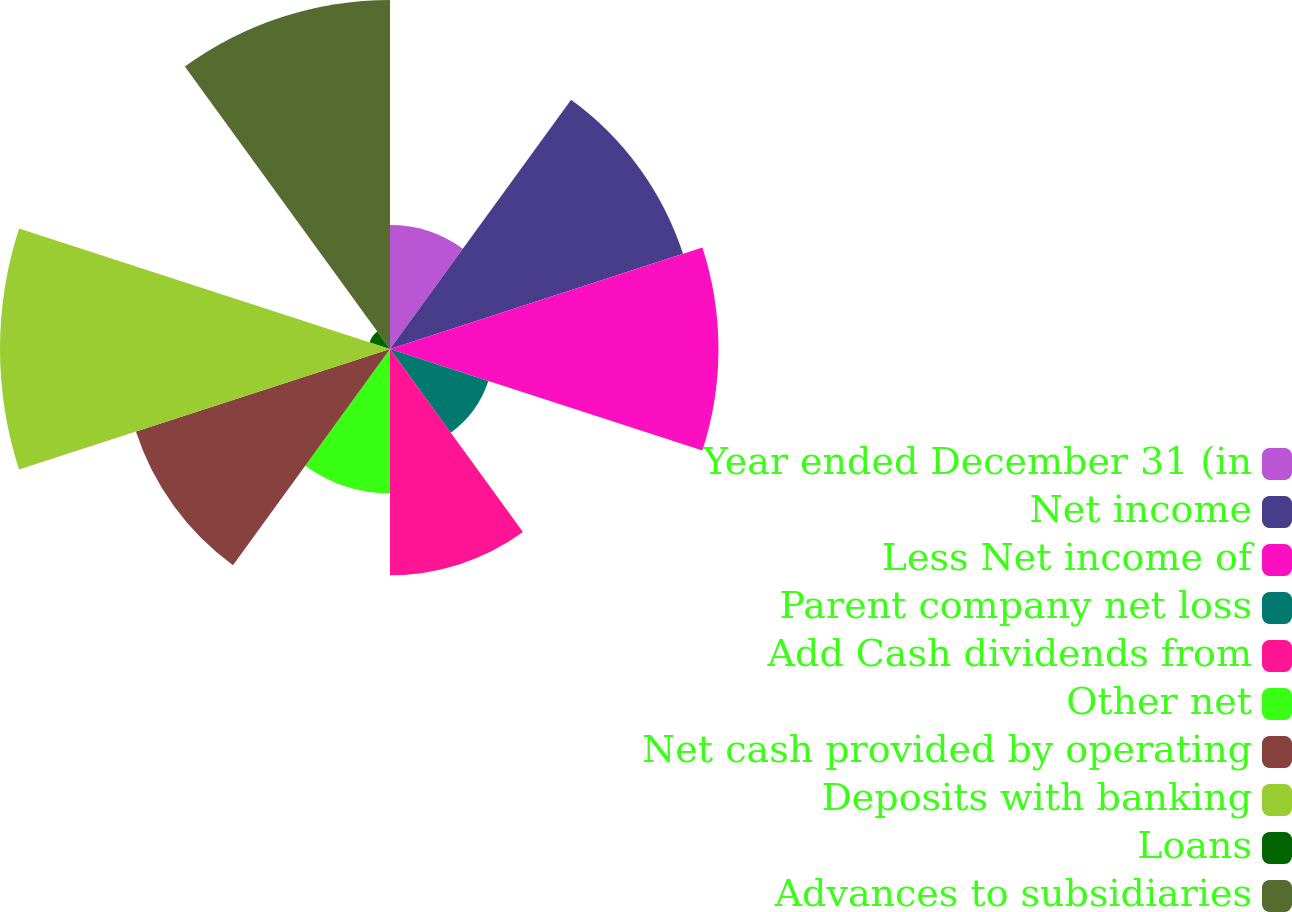Convert chart to OTSL. <chart><loc_0><loc_0><loc_500><loc_500><pie_chart><fcel>Year ended December 31 (in<fcel>Net income<fcel>Less Net income of<fcel>Parent company net loss<fcel>Add Cash dividends from<fcel>Other net<fcel>Net cash provided by operating<fcel>Deposits with banking<fcel>Loans<fcel>Advances to subsidiaries<nl><fcel>5.48%<fcel>13.62%<fcel>14.52%<fcel>4.57%<fcel>10.0%<fcel>6.38%<fcel>11.81%<fcel>17.24%<fcel>0.95%<fcel>15.43%<nl></chart> 